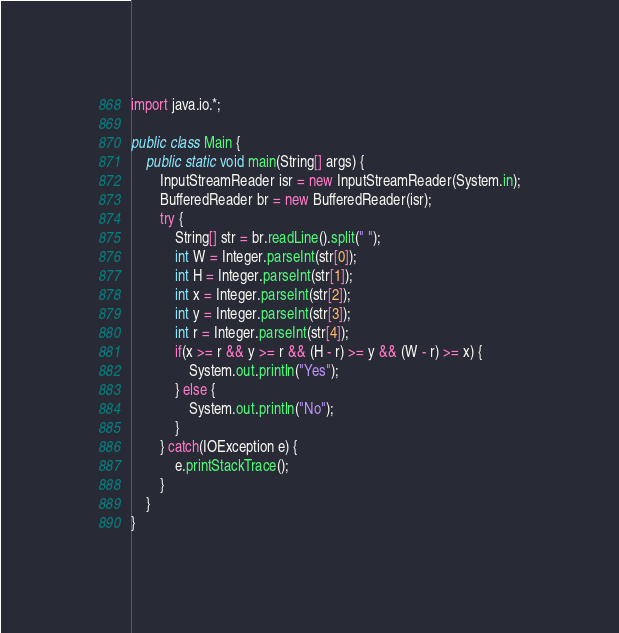Convert code to text. <code><loc_0><loc_0><loc_500><loc_500><_Java_>import java.io.*;

public class Main {
    public static void main(String[] args) {
        InputStreamReader isr = new InputStreamReader(System.in);
        BufferedReader br = new BufferedReader(isr);
        try {
            String[] str = br.readLine().split(" ");
            int W = Integer.parseInt(str[0]);
            int H = Integer.parseInt(str[1]);
            int x = Integer.parseInt(str[2]);
            int y = Integer.parseInt(str[3]);
            int r = Integer.parseInt(str[4]);
            if(x >= r && y >= r && (H - r) >= y && (W - r) >= x) {
                System.out.println("Yes");
            } else {
                System.out.println("No");
            }
        } catch(IOException e) {
            e.printStackTrace();
        }
    }
}</code> 